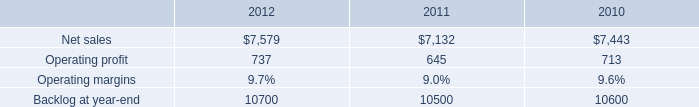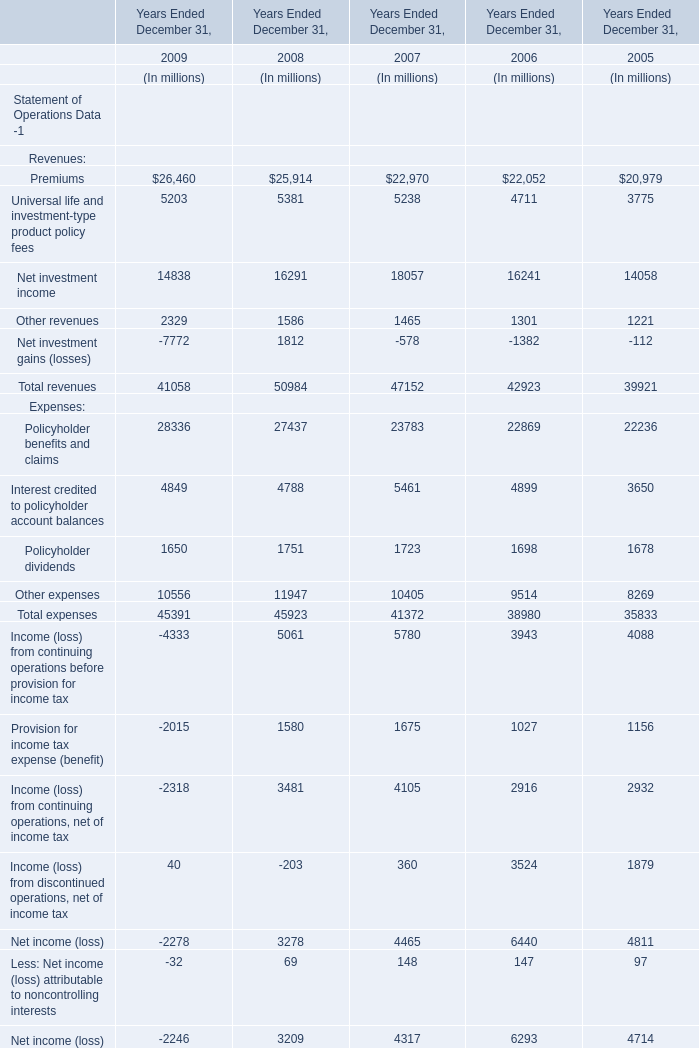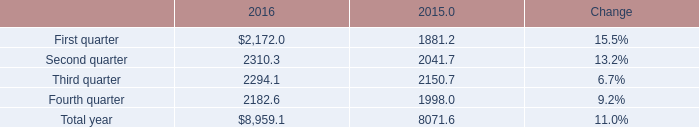what was the ratio of the mst 2019 change in net sales compared to msf from 2010 to 2011 
Computations: ((7132 - 7443) / 533)
Answer: -0.58349. 